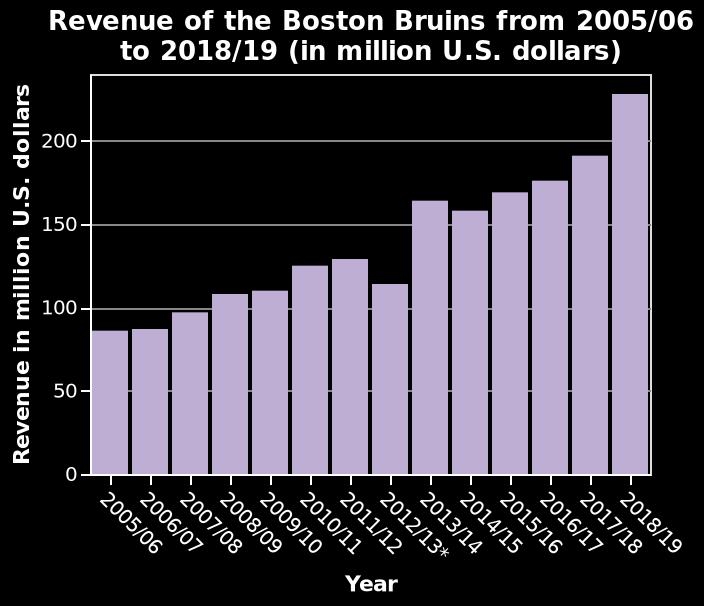<image>
What is the unit of measurement for revenue in the bar chart?  The unit of measurement for revenue in the bar chart is million U.S. dollars. What is the lowest recorded revenue for the Boston Bruins within the given time period? Similarly, the bar chart does not provide specific data for the lowest recorded revenue, as it only illustrates the revenue trend over time. Which years saw the sharpest increase in revenue?  The years 2013/14 saw the sharpest increase in revenue. please enumerates aspects of the construction of the chart Revenue of the Boston Bruins from 2005/06 to 2018/19 (in million U.S. dollars) is a bar chart. The x-axis shows Year. There is a linear scale of range 0 to 200 along the y-axis, labeled Revenue in million U.S. dollars. 